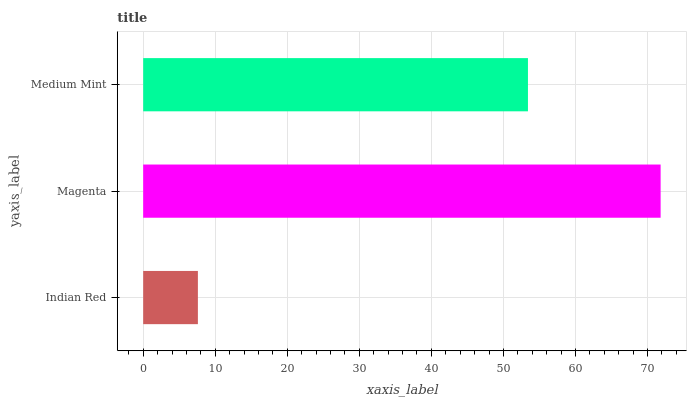Is Indian Red the minimum?
Answer yes or no. Yes. Is Magenta the maximum?
Answer yes or no. Yes. Is Medium Mint the minimum?
Answer yes or no. No. Is Medium Mint the maximum?
Answer yes or no. No. Is Magenta greater than Medium Mint?
Answer yes or no. Yes. Is Medium Mint less than Magenta?
Answer yes or no. Yes. Is Medium Mint greater than Magenta?
Answer yes or no. No. Is Magenta less than Medium Mint?
Answer yes or no. No. Is Medium Mint the high median?
Answer yes or no. Yes. Is Medium Mint the low median?
Answer yes or no. Yes. Is Indian Red the high median?
Answer yes or no. No. Is Magenta the low median?
Answer yes or no. No. 